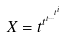Convert formula to latex. <formula><loc_0><loc_0><loc_500><loc_500>X = t ^ { t ^ { t ^ { \dots ^ { t ^ { i } } } } }</formula> 